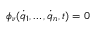<formula> <loc_0><loc_0><loc_500><loc_500>\phi _ { \nu } ( { \dot { q } } _ { 1 } , \dots , { \dot { q } } _ { n } , t ) = 0</formula> 